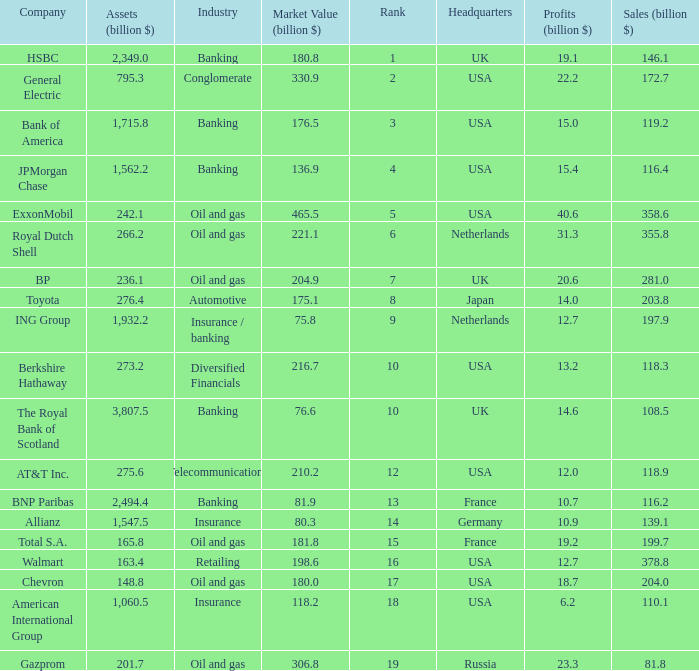What is the market value of a company in billions that has 172.7 billion in sales?  330.9. 